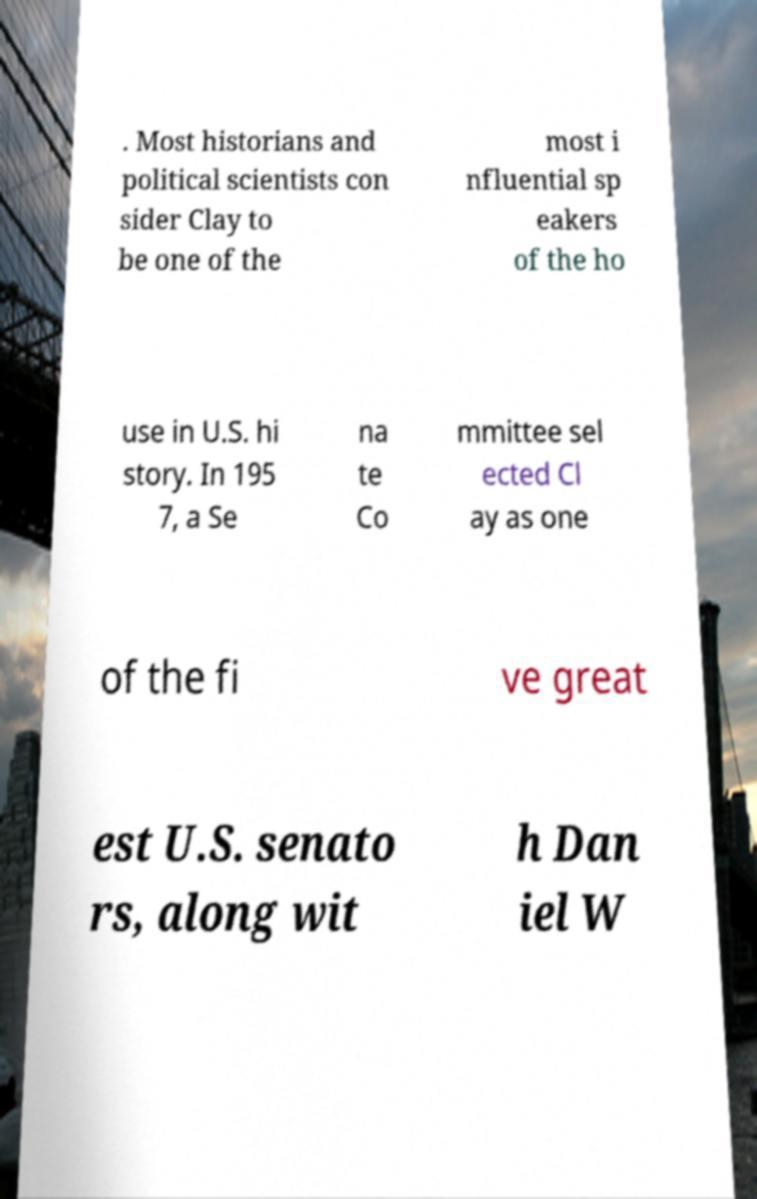I need the written content from this picture converted into text. Can you do that? . Most historians and political scientists con sider Clay to be one of the most i nfluential sp eakers of the ho use in U.S. hi story. In 195 7, a Se na te Co mmittee sel ected Cl ay as one of the fi ve great est U.S. senato rs, along wit h Dan iel W 